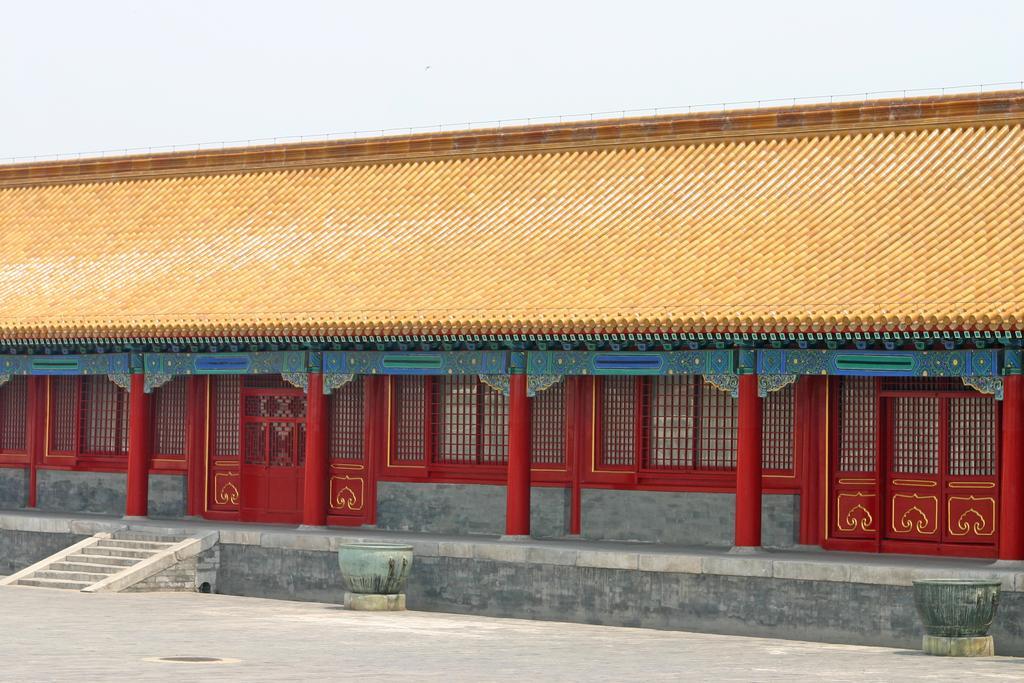Describe this image in one or two sentences. In this image we can see pots on the floor, steps, pillars, building, welded mesh wires, doors, roof and the sky. 